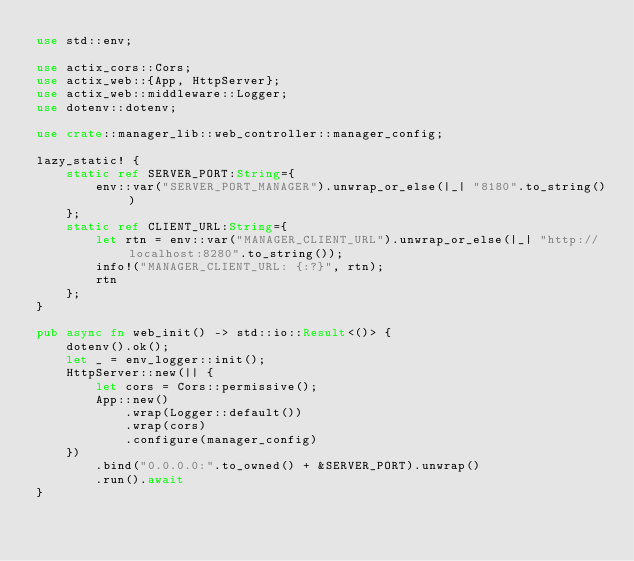Convert code to text. <code><loc_0><loc_0><loc_500><loc_500><_Rust_>use std::env;

use actix_cors::Cors;
use actix_web::{App, HttpServer};
use actix_web::middleware::Logger;
use dotenv::dotenv;

use crate::manager_lib::web_controller::manager_config;

lazy_static! {
    static ref SERVER_PORT:String={
        env::var("SERVER_PORT_MANAGER").unwrap_or_else(|_| "8180".to_string())
    };
    static ref CLIENT_URL:String={
        let rtn = env::var("MANAGER_CLIENT_URL").unwrap_or_else(|_| "http://localhost:8280".to_string());
        info!("MANAGER_CLIENT_URL: {:?}", rtn);
        rtn
    };
}

pub async fn web_init() -> std::io::Result<()> {
    dotenv().ok();
    let _ = env_logger::init();
    HttpServer::new(|| {
        let cors = Cors::permissive();
        App::new()
            .wrap(Logger::default())
            .wrap(cors)
            .configure(manager_config)
    })
        .bind("0.0.0.0:".to_owned() + &SERVER_PORT).unwrap()
        .run().await
}
</code> 